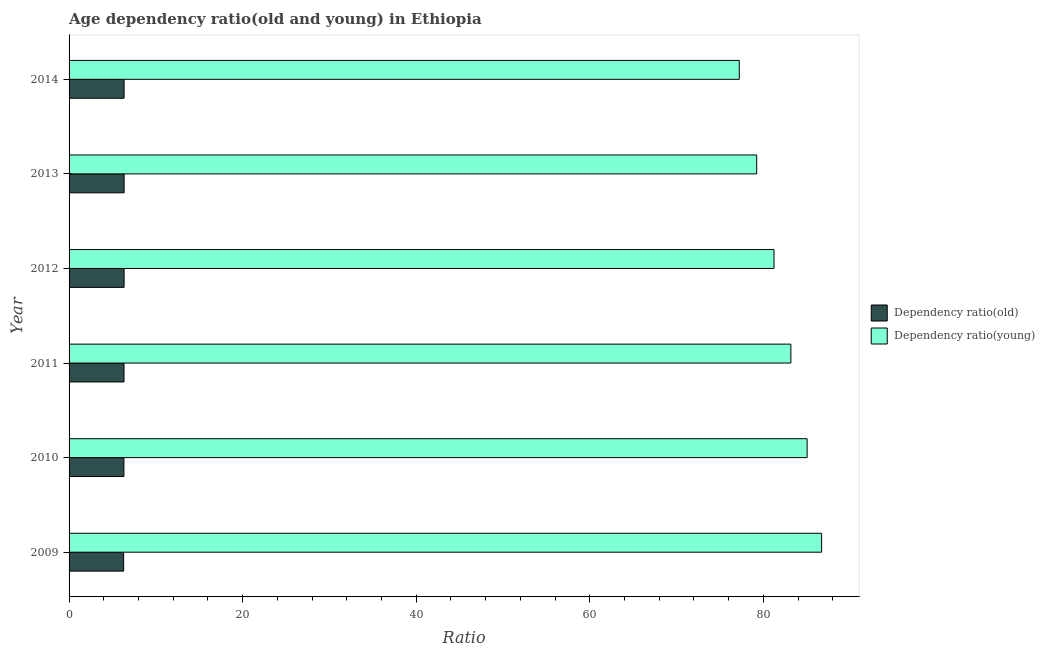How many different coloured bars are there?
Provide a succinct answer. 2. How many groups of bars are there?
Your response must be concise. 6. Are the number of bars per tick equal to the number of legend labels?
Keep it short and to the point. Yes. Are the number of bars on each tick of the Y-axis equal?
Give a very brief answer. Yes. In how many cases, is the number of bars for a given year not equal to the number of legend labels?
Offer a very short reply. 0. What is the age dependency ratio(old) in 2011?
Give a very brief answer. 6.33. Across all years, what is the maximum age dependency ratio(young)?
Offer a very short reply. 86.71. Across all years, what is the minimum age dependency ratio(young)?
Your response must be concise. 77.23. In which year was the age dependency ratio(young) maximum?
Your answer should be very brief. 2009. What is the total age dependency ratio(old) in the graph?
Your answer should be compact. 37.96. What is the difference between the age dependency ratio(old) in 2010 and that in 2014?
Give a very brief answer. -0.02. What is the difference between the age dependency ratio(young) in 2010 and the age dependency ratio(old) in 2014?
Give a very brief answer. 78.71. What is the average age dependency ratio(old) per year?
Your answer should be very brief. 6.33. In the year 2012, what is the difference between the age dependency ratio(old) and age dependency ratio(young)?
Your answer should be compact. -74.89. What is the difference between the highest and the second highest age dependency ratio(old)?
Give a very brief answer. 0. What is the difference between the highest and the lowest age dependency ratio(young)?
Make the answer very short. 9.48. In how many years, is the age dependency ratio(old) greater than the average age dependency ratio(old) taken over all years?
Your answer should be very brief. 4. What does the 2nd bar from the top in 2011 represents?
Provide a succinct answer. Dependency ratio(old). What does the 1st bar from the bottom in 2010 represents?
Provide a succinct answer. Dependency ratio(old). Does the graph contain grids?
Keep it short and to the point. No. How many legend labels are there?
Offer a very short reply. 2. How are the legend labels stacked?
Provide a succinct answer. Vertical. What is the title of the graph?
Your response must be concise. Age dependency ratio(old and young) in Ethiopia. Does "Registered firms" appear as one of the legend labels in the graph?
Provide a succinct answer. No. What is the label or title of the X-axis?
Provide a succinct answer. Ratio. What is the label or title of the Y-axis?
Ensure brevity in your answer.  Year. What is the Ratio in Dependency ratio(old) in 2009?
Your answer should be very brief. 6.29. What is the Ratio in Dependency ratio(young) in 2009?
Ensure brevity in your answer.  86.71. What is the Ratio of Dependency ratio(old) in 2010?
Give a very brief answer. 6.32. What is the Ratio of Dependency ratio(young) in 2010?
Offer a terse response. 85.05. What is the Ratio in Dependency ratio(old) in 2011?
Your response must be concise. 6.33. What is the Ratio of Dependency ratio(young) in 2011?
Offer a very short reply. 83.17. What is the Ratio of Dependency ratio(old) in 2012?
Provide a succinct answer. 6.34. What is the Ratio of Dependency ratio(young) in 2012?
Your answer should be very brief. 81.23. What is the Ratio in Dependency ratio(old) in 2013?
Your answer should be very brief. 6.34. What is the Ratio in Dependency ratio(young) in 2013?
Give a very brief answer. 79.24. What is the Ratio of Dependency ratio(old) in 2014?
Your answer should be compact. 6.34. What is the Ratio of Dependency ratio(young) in 2014?
Provide a short and direct response. 77.23. Across all years, what is the maximum Ratio in Dependency ratio(old)?
Make the answer very short. 6.34. Across all years, what is the maximum Ratio in Dependency ratio(young)?
Give a very brief answer. 86.71. Across all years, what is the minimum Ratio in Dependency ratio(old)?
Give a very brief answer. 6.29. Across all years, what is the minimum Ratio in Dependency ratio(young)?
Provide a succinct answer. 77.23. What is the total Ratio of Dependency ratio(old) in the graph?
Make the answer very short. 37.96. What is the total Ratio of Dependency ratio(young) in the graph?
Keep it short and to the point. 492.63. What is the difference between the Ratio of Dependency ratio(old) in 2009 and that in 2010?
Provide a short and direct response. -0.03. What is the difference between the Ratio in Dependency ratio(young) in 2009 and that in 2010?
Your answer should be compact. 1.67. What is the difference between the Ratio in Dependency ratio(old) in 2009 and that in 2011?
Your response must be concise. -0.04. What is the difference between the Ratio of Dependency ratio(young) in 2009 and that in 2011?
Provide a short and direct response. 3.54. What is the difference between the Ratio in Dependency ratio(old) in 2009 and that in 2012?
Keep it short and to the point. -0.05. What is the difference between the Ratio of Dependency ratio(young) in 2009 and that in 2012?
Provide a short and direct response. 5.48. What is the difference between the Ratio in Dependency ratio(old) in 2009 and that in 2013?
Give a very brief answer. -0.06. What is the difference between the Ratio in Dependency ratio(young) in 2009 and that in 2013?
Offer a terse response. 7.48. What is the difference between the Ratio of Dependency ratio(old) in 2009 and that in 2014?
Your answer should be very brief. -0.05. What is the difference between the Ratio in Dependency ratio(young) in 2009 and that in 2014?
Offer a very short reply. 9.48. What is the difference between the Ratio in Dependency ratio(old) in 2010 and that in 2011?
Your response must be concise. -0.01. What is the difference between the Ratio in Dependency ratio(young) in 2010 and that in 2011?
Offer a very short reply. 1.87. What is the difference between the Ratio of Dependency ratio(old) in 2010 and that in 2012?
Ensure brevity in your answer.  -0.02. What is the difference between the Ratio of Dependency ratio(young) in 2010 and that in 2012?
Offer a very short reply. 3.82. What is the difference between the Ratio in Dependency ratio(old) in 2010 and that in 2013?
Give a very brief answer. -0.03. What is the difference between the Ratio in Dependency ratio(young) in 2010 and that in 2013?
Offer a very short reply. 5.81. What is the difference between the Ratio of Dependency ratio(old) in 2010 and that in 2014?
Ensure brevity in your answer.  -0.02. What is the difference between the Ratio of Dependency ratio(young) in 2010 and that in 2014?
Make the answer very short. 7.82. What is the difference between the Ratio in Dependency ratio(old) in 2011 and that in 2012?
Your answer should be very brief. -0.01. What is the difference between the Ratio of Dependency ratio(young) in 2011 and that in 2012?
Make the answer very short. 1.94. What is the difference between the Ratio of Dependency ratio(old) in 2011 and that in 2013?
Ensure brevity in your answer.  -0.01. What is the difference between the Ratio in Dependency ratio(young) in 2011 and that in 2013?
Make the answer very short. 3.94. What is the difference between the Ratio of Dependency ratio(old) in 2011 and that in 2014?
Make the answer very short. -0.01. What is the difference between the Ratio in Dependency ratio(young) in 2011 and that in 2014?
Ensure brevity in your answer.  5.94. What is the difference between the Ratio of Dependency ratio(old) in 2012 and that in 2013?
Offer a terse response. -0. What is the difference between the Ratio of Dependency ratio(young) in 2012 and that in 2013?
Give a very brief answer. 1.99. What is the difference between the Ratio of Dependency ratio(young) in 2012 and that in 2014?
Give a very brief answer. 4. What is the difference between the Ratio in Dependency ratio(old) in 2013 and that in 2014?
Provide a succinct answer. 0. What is the difference between the Ratio of Dependency ratio(young) in 2013 and that in 2014?
Make the answer very short. 2.01. What is the difference between the Ratio in Dependency ratio(old) in 2009 and the Ratio in Dependency ratio(young) in 2010?
Ensure brevity in your answer.  -78.76. What is the difference between the Ratio in Dependency ratio(old) in 2009 and the Ratio in Dependency ratio(young) in 2011?
Offer a terse response. -76.89. What is the difference between the Ratio in Dependency ratio(old) in 2009 and the Ratio in Dependency ratio(young) in 2012?
Offer a terse response. -74.94. What is the difference between the Ratio in Dependency ratio(old) in 2009 and the Ratio in Dependency ratio(young) in 2013?
Provide a succinct answer. -72.95. What is the difference between the Ratio in Dependency ratio(old) in 2009 and the Ratio in Dependency ratio(young) in 2014?
Make the answer very short. -70.94. What is the difference between the Ratio of Dependency ratio(old) in 2010 and the Ratio of Dependency ratio(young) in 2011?
Make the answer very short. -76.85. What is the difference between the Ratio in Dependency ratio(old) in 2010 and the Ratio in Dependency ratio(young) in 2012?
Offer a terse response. -74.91. What is the difference between the Ratio in Dependency ratio(old) in 2010 and the Ratio in Dependency ratio(young) in 2013?
Your answer should be very brief. -72.92. What is the difference between the Ratio of Dependency ratio(old) in 2010 and the Ratio of Dependency ratio(young) in 2014?
Offer a terse response. -70.91. What is the difference between the Ratio in Dependency ratio(old) in 2011 and the Ratio in Dependency ratio(young) in 2012?
Your response must be concise. -74.9. What is the difference between the Ratio of Dependency ratio(old) in 2011 and the Ratio of Dependency ratio(young) in 2013?
Your answer should be very brief. -72.91. What is the difference between the Ratio in Dependency ratio(old) in 2011 and the Ratio in Dependency ratio(young) in 2014?
Your answer should be very brief. -70.9. What is the difference between the Ratio in Dependency ratio(old) in 2012 and the Ratio in Dependency ratio(young) in 2013?
Your response must be concise. -72.9. What is the difference between the Ratio in Dependency ratio(old) in 2012 and the Ratio in Dependency ratio(young) in 2014?
Your response must be concise. -70.89. What is the difference between the Ratio in Dependency ratio(old) in 2013 and the Ratio in Dependency ratio(young) in 2014?
Your response must be concise. -70.88. What is the average Ratio of Dependency ratio(old) per year?
Keep it short and to the point. 6.33. What is the average Ratio in Dependency ratio(young) per year?
Provide a short and direct response. 82.1. In the year 2009, what is the difference between the Ratio of Dependency ratio(old) and Ratio of Dependency ratio(young)?
Provide a succinct answer. -80.43. In the year 2010, what is the difference between the Ratio of Dependency ratio(old) and Ratio of Dependency ratio(young)?
Offer a very short reply. -78.73. In the year 2011, what is the difference between the Ratio of Dependency ratio(old) and Ratio of Dependency ratio(young)?
Your answer should be compact. -76.84. In the year 2012, what is the difference between the Ratio of Dependency ratio(old) and Ratio of Dependency ratio(young)?
Provide a succinct answer. -74.89. In the year 2013, what is the difference between the Ratio of Dependency ratio(old) and Ratio of Dependency ratio(young)?
Give a very brief answer. -72.89. In the year 2014, what is the difference between the Ratio of Dependency ratio(old) and Ratio of Dependency ratio(young)?
Ensure brevity in your answer.  -70.89. What is the ratio of the Ratio in Dependency ratio(young) in 2009 to that in 2010?
Offer a terse response. 1.02. What is the ratio of the Ratio of Dependency ratio(old) in 2009 to that in 2011?
Your response must be concise. 0.99. What is the ratio of the Ratio of Dependency ratio(young) in 2009 to that in 2011?
Make the answer very short. 1.04. What is the ratio of the Ratio of Dependency ratio(old) in 2009 to that in 2012?
Your answer should be compact. 0.99. What is the ratio of the Ratio in Dependency ratio(young) in 2009 to that in 2012?
Give a very brief answer. 1.07. What is the ratio of the Ratio in Dependency ratio(young) in 2009 to that in 2013?
Your response must be concise. 1.09. What is the ratio of the Ratio in Dependency ratio(young) in 2009 to that in 2014?
Your answer should be compact. 1.12. What is the ratio of the Ratio of Dependency ratio(old) in 2010 to that in 2011?
Ensure brevity in your answer.  1. What is the ratio of the Ratio in Dependency ratio(young) in 2010 to that in 2011?
Your answer should be compact. 1.02. What is the ratio of the Ratio of Dependency ratio(young) in 2010 to that in 2012?
Keep it short and to the point. 1.05. What is the ratio of the Ratio of Dependency ratio(young) in 2010 to that in 2013?
Offer a very short reply. 1.07. What is the ratio of the Ratio of Dependency ratio(young) in 2010 to that in 2014?
Make the answer very short. 1.1. What is the ratio of the Ratio in Dependency ratio(young) in 2011 to that in 2012?
Ensure brevity in your answer.  1.02. What is the ratio of the Ratio of Dependency ratio(old) in 2011 to that in 2013?
Your response must be concise. 1. What is the ratio of the Ratio of Dependency ratio(young) in 2011 to that in 2013?
Offer a very short reply. 1.05. What is the ratio of the Ratio in Dependency ratio(old) in 2011 to that in 2014?
Offer a terse response. 1. What is the ratio of the Ratio of Dependency ratio(young) in 2011 to that in 2014?
Your answer should be very brief. 1.08. What is the ratio of the Ratio of Dependency ratio(young) in 2012 to that in 2013?
Ensure brevity in your answer.  1.03. What is the ratio of the Ratio in Dependency ratio(old) in 2012 to that in 2014?
Provide a short and direct response. 1. What is the ratio of the Ratio in Dependency ratio(young) in 2012 to that in 2014?
Make the answer very short. 1.05. What is the ratio of the Ratio in Dependency ratio(young) in 2013 to that in 2014?
Provide a succinct answer. 1.03. What is the difference between the highest and the second highest Ratio in Dependency ratio(old)?
Keep it short and to the point. 0. What is the difference between the highest and the second highest Ratio in Dependency ratio(young)?
Offer a very short reply. 1.67. What is the difference between the highest and the lowest Ratio of Dependency ratio(old)?
Make the answer very short. 0.06. What is the difference between the highest and the lowest Ratio in Dependency ratio(young)?
Make the answer very short. 9.48. 